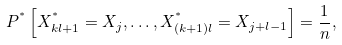Convert formula to latex. <formula><loc_0><loc_0><loc_500><loc_500>P ^ { ^ { * } } \left [ X ^ { ^ { * } } _ { k l + 1 } = X _ { j } , \dots , X ^ { ^ { * } } _ { ( k + 1 ) l } = X _ { j + l - 1 } \right ] = \frac { 1 } { n } ,</formula> 